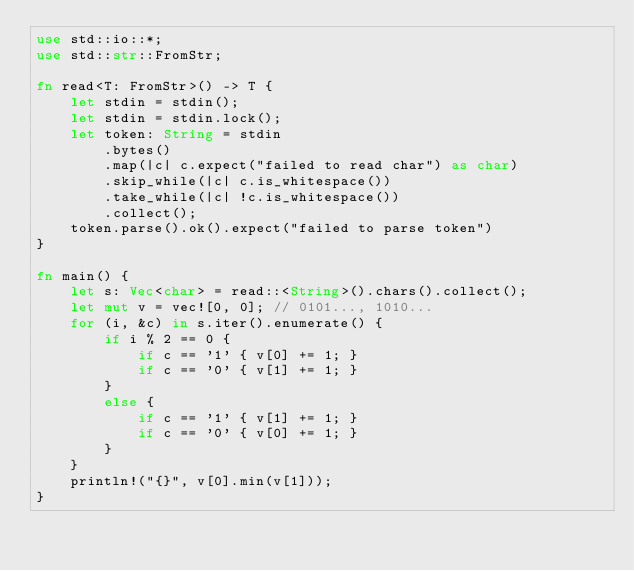Convert code to text. <code><loc_0><loc_0><loc_500><loc_500><_Rust_>use std::io::*;
use std::str::FromStr;

fn read<T: FromStr>() -> T {
    let stdin = stdin();
    let stdin = stdin.lock();
    let token: String = stdin
        .bytes()
        .map(|c| c.expect("failed to read char") as char)
        .skip_while(|c| c.is_whitespace())
        .take_while(|c| !c.is_whitespace())
        .collect();
    token.parse().ok().expect("failed to parse token")
}

fn main() {
    let s: Vec<char> = read::<String>().chars().collect();
    let mut v = vec![0, 0]; // 0101..., 1010...
    for (i, &c) in s.iter().enumerate() {
        if i % 2 == 0 {
            if c == '1' { v[0] += 1; }
            if c == '0' { v[1] += 1; }
        }
        else {
            if c == '1' { v[1] += 1; }
            if c == '0' { v[0] += 1; }
        }
    }
    println!("{}", v[0].min(v[1]));
}
</code> 